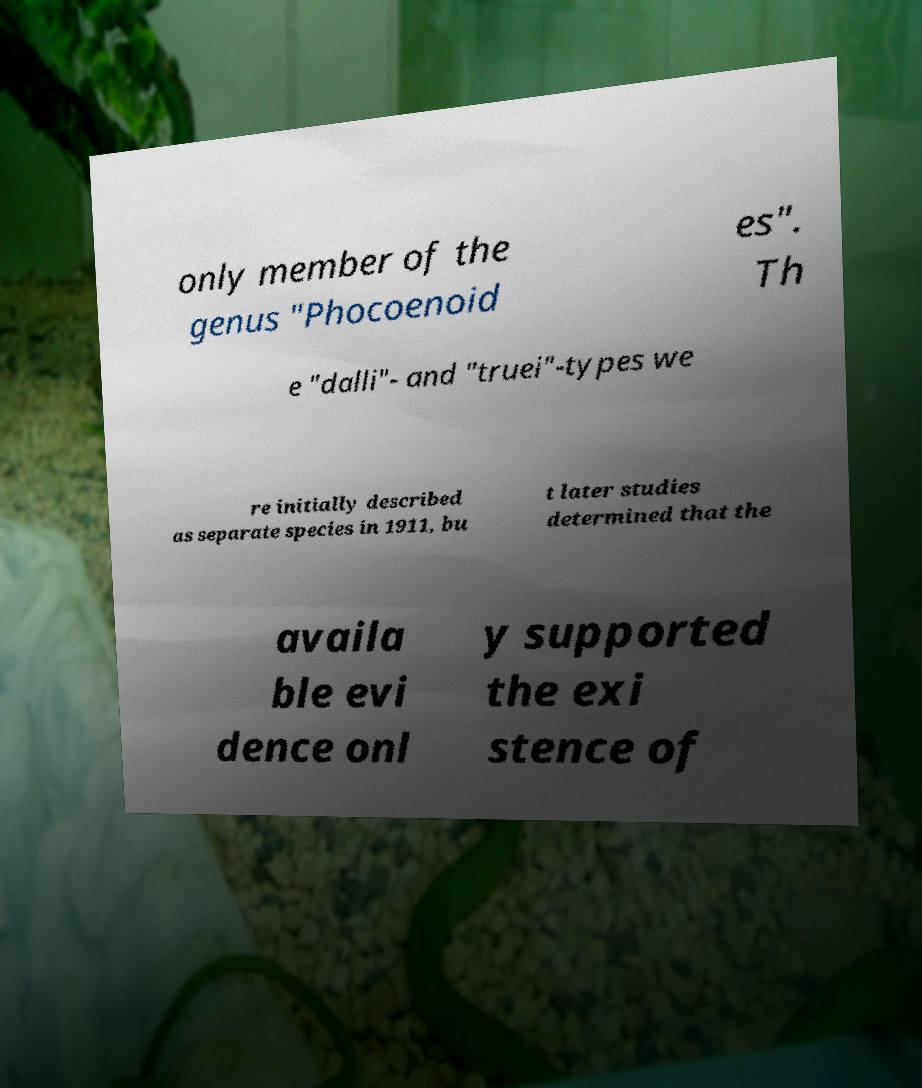There's text embedded in this image that I need extracted. Can you transcribe it verbatim? only member of the genus "Phocoenoid es". Th e "dalli"- and "truei"-types we re initially described as separate species in 1911, bu t later studies determined that the availa ble evi dence onl y supported the exi stence of 